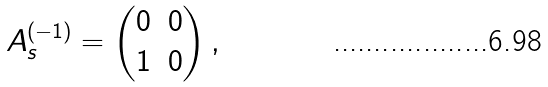<formula> <loc_0><loc_0><loc_500><loc_500>A ^ { ( - 1 ) } _ { s } = \begin{pmatrix} 0 & 0 \\ 1 & 0 \end{pmatrix} ,</formula> 